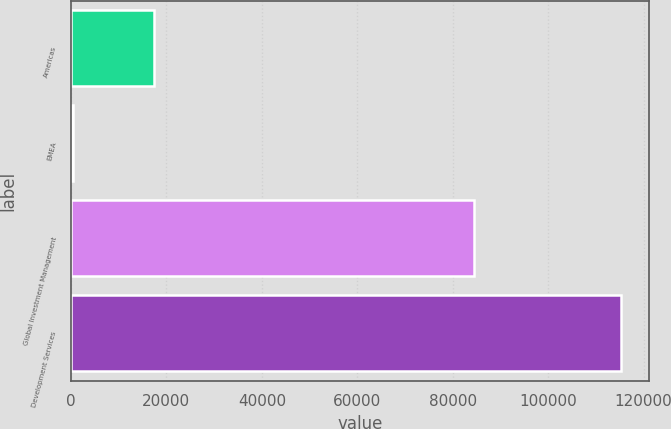Convert chart. <chart><loc_0><loc_0><loc_500><loc_500><bar_chart><fcel>Americas<fcel>EMEA<fcel>Global Investment Management<fcel>Development Services<nl><fcel>17380<fcel>392<fcel>84534<fcel>115326<nl></chart> 